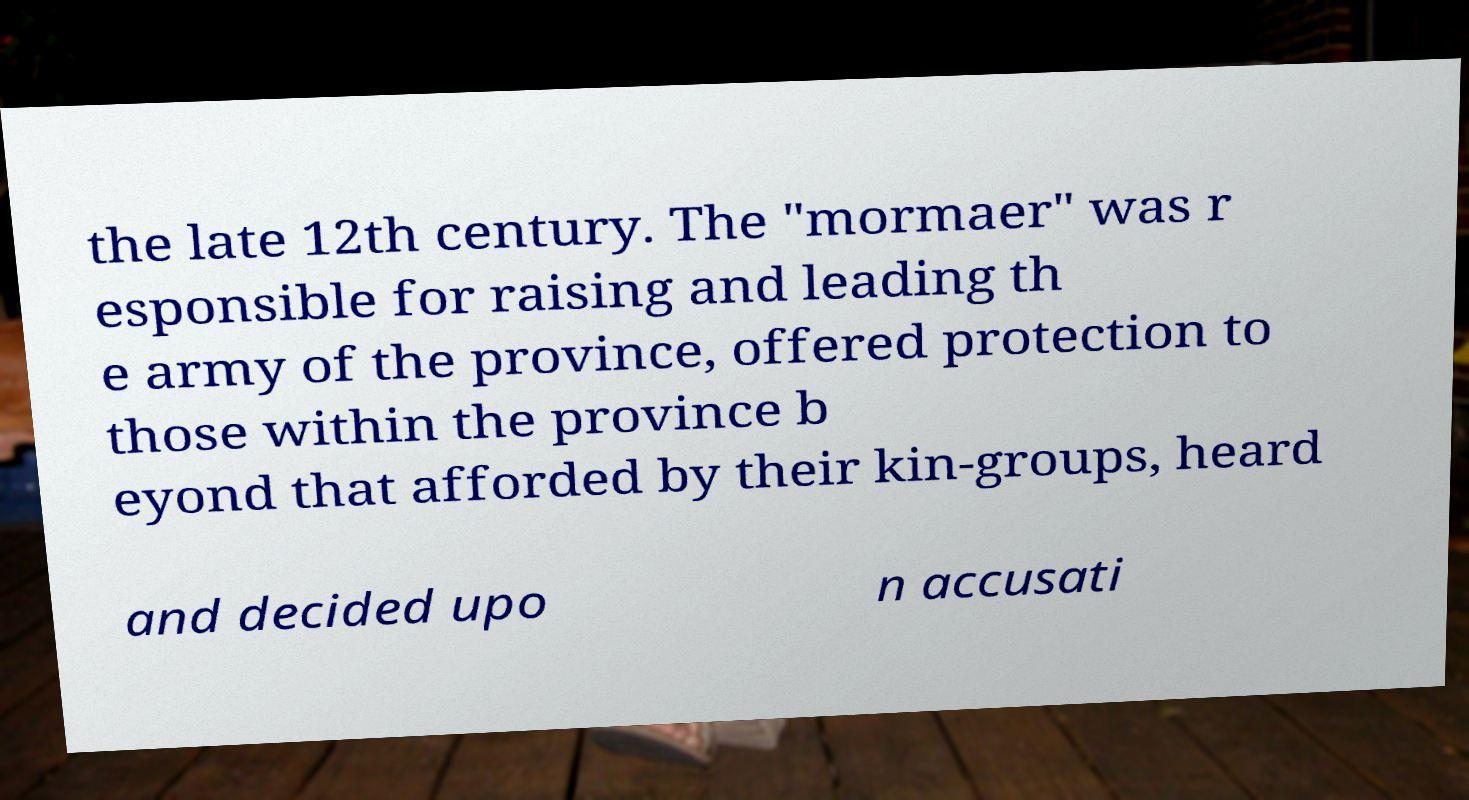Could you assist in decoding the text presented in this image and type it out clearly? the late 12th century. The "mormaer" was r esponsible for raising and leading th e army of the province, offered protection to those within the province b eyond that afforded by their kin-groups, heard and decided upo n accusati 